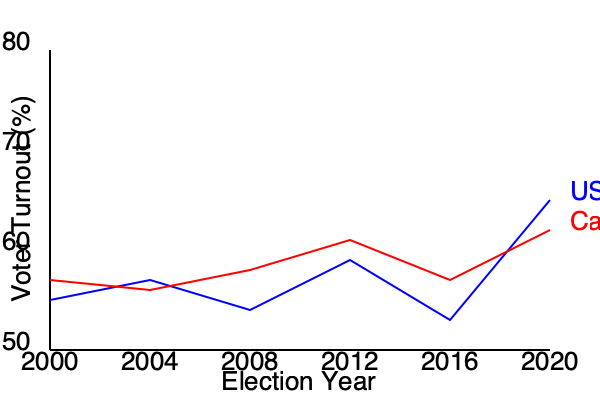Analyze the voter turnout trends in the USA and Canada from 2000 to 2020. What factors might explain the divergence in voter participation between these two North American countries in recent elections, and how might this data be interpreted with skepticism? To answer this question, we need to critically analyze the graph and consider potential factors influencing voter turnout:

1. Trend analysis:
   - USA: Shows a generally increasing trend from 2000 to 2020, with a significant spike in 2020.
   - Canada: Displays a more stable trend with slight fluctuations and a modest increase in 2020.

2. Divergence:
   - The gap between USA and Canada widens significantly in 2020.
   - USA turnout surpasses Canada's for the first time in the given period.

3. Potential factors for divergence:
   a) Political climate: Increased polarization in the USA might have motivated higher turnout.
   b) Voting systems: Differences in electoral systems (e.g., compulsory voting, ease of registration) could impact participation.
   c) Media influence: Varying levels of media coverage and political engagement in each country.
   d) Demographic changes: Shifts in population composition and voting age citizens.

4. Skeptical interpretation:
   a) Data reliability: Question the accuracy and consistency of data collection methods across countries and years.
   b) External factors: Consider the impact of the COVID-19 pandemic on the 2020 election, which might have affected turnout differently in each country.
   c) Definition of turnout: Examine how "voter turnout" is calculated (e.g., registered voters vs. eligible population) and if it's consistent between countries.
   d) Contextual factors: Look into specific events or policy changes that might have influenced turnout in particular years.
   e) Long-term trends: Consider whether the 2020 divergence is an anomaly or part of a longer-term trend not fully captured in this timeframe.

5. Limitations of the data:
   a) Limited timeframe: The graph only shows 20 years, which may not be sufficient to draw definitive conclusions about long-term trends.
   b) Lack of error bars or confidence intervals: The precise nature of the lines doesn't account for potential margins of error in the data.
   c) Absence of midterm or non-federal elections: The graph likely only shows presidential/federal elections, which may not represent overall political engagement.

In conclusion, while the graph suggests a growing divergence in voter turnout between the USA and Canada, particularly in 2020, a skeptical interpretation would question the underlying data, consider contextual factors, and avoid drawing sweeping conclusions without further evidence and analysis.
Answer: Diverging trends possibly due to political polarization, voting systems, and media influence; interpret skeptically considering data reliability, pandemic effects, and limited timeframe. 